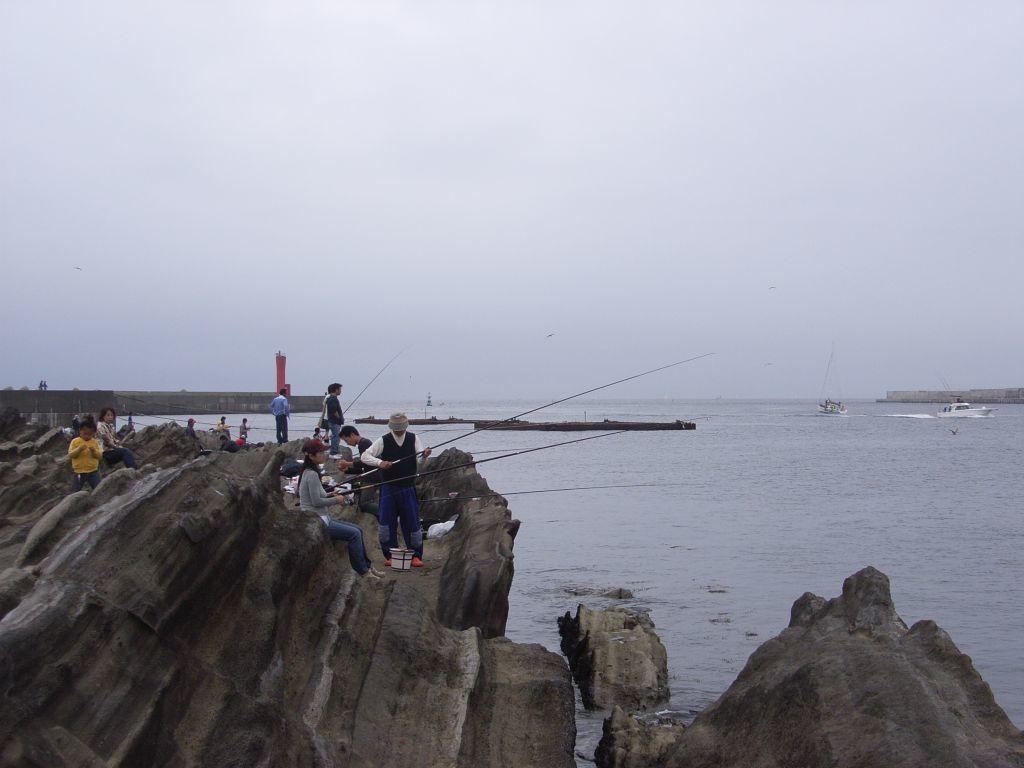Can you describe this image briefly? In this image there is the sky truncated towards the top of the image, there is a sea truncated towards the right of the image, there is a boat on the sea, there are rocks truncated towards the bottom of the image, there are rocks truncated towards the left of the image, there is a wall truncated towards the left of the image, there are persons on the rock, there are objects on the rock, there are persons holding an object. 